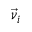<formula> <loc_0><loc_0><loc_500><loc_500>\vec { \nu } _ { i }</formula> 